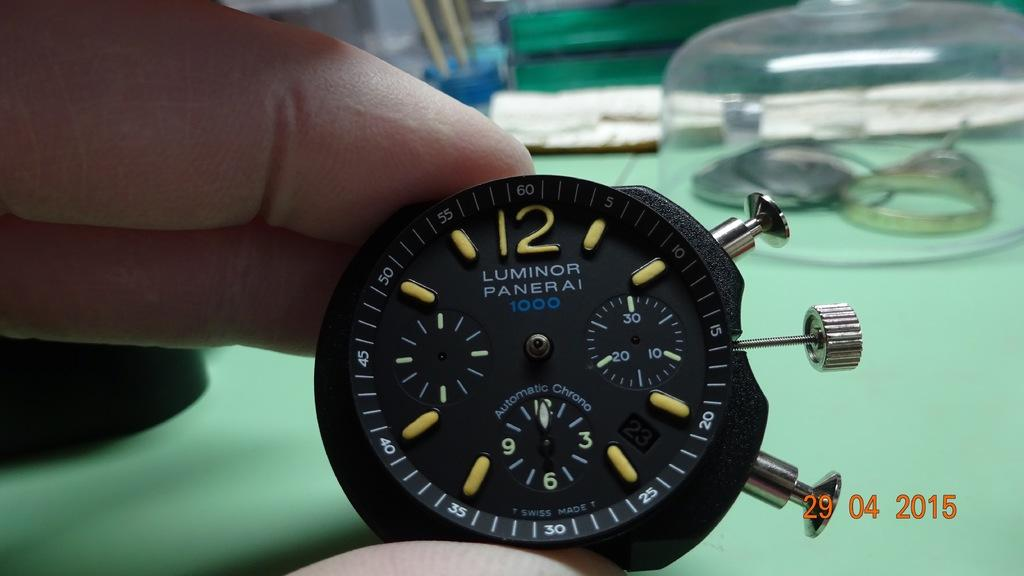Provide a one-sentence caption for the provided image. A photo of an elegant black and gold stopwatch bears a 2015 time stamp. 